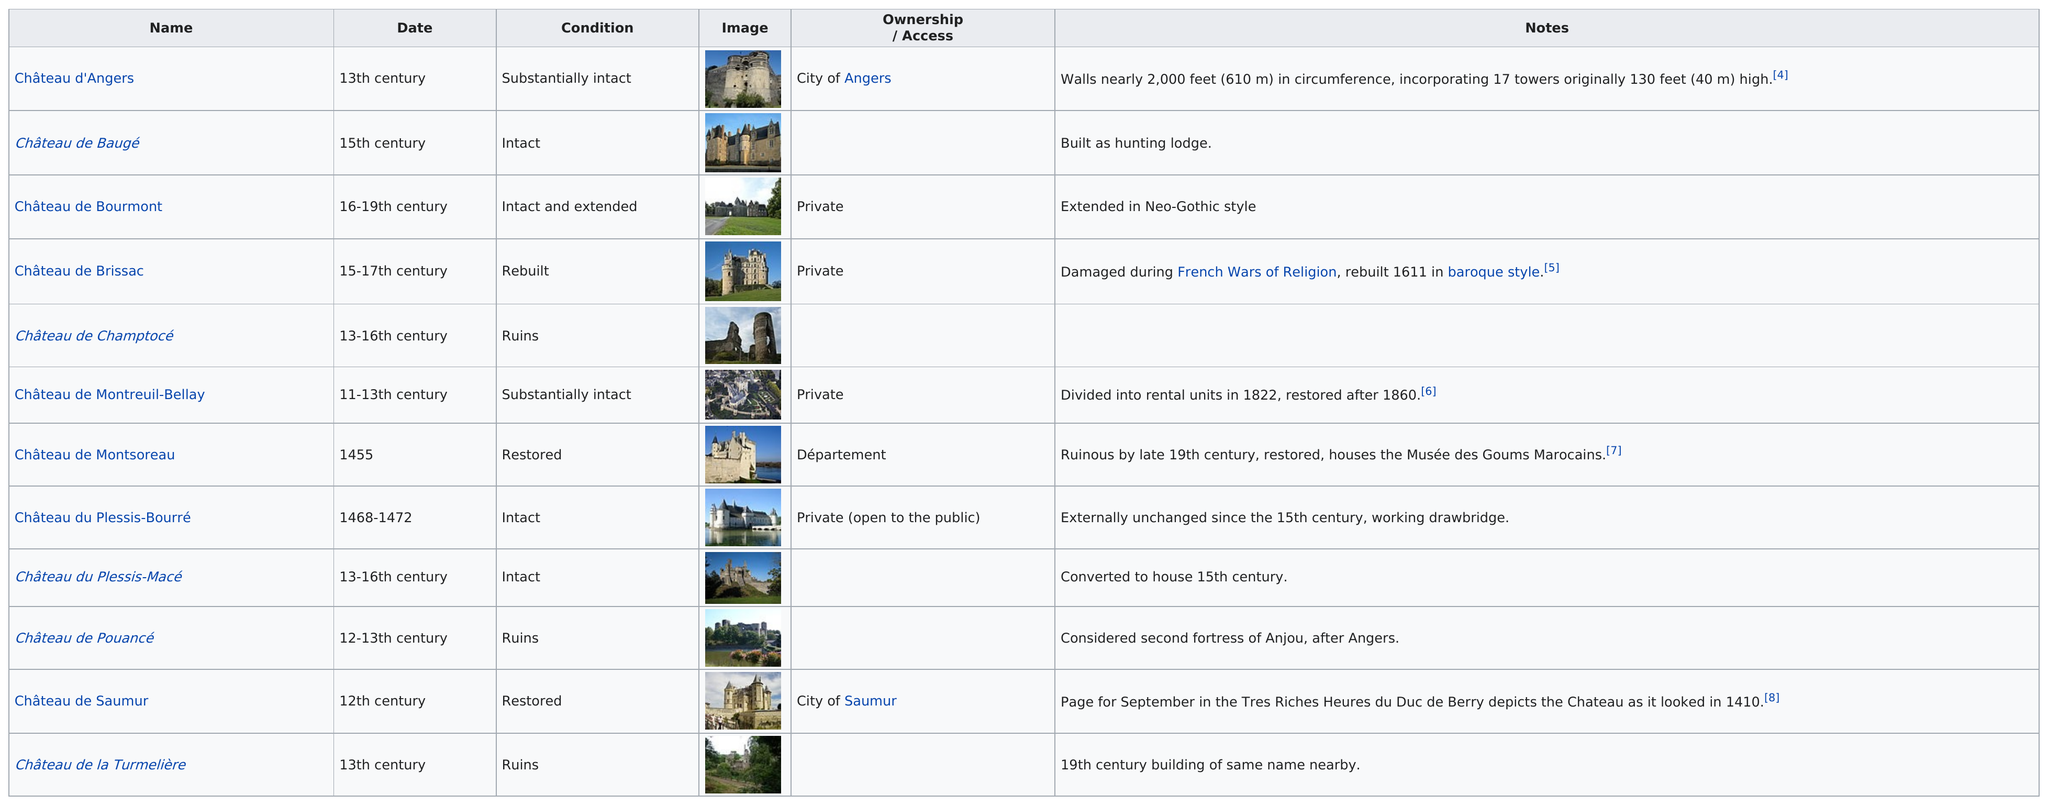List a handful of essential elements in this visual. Nearly three out of these castles are currently in ruins. The Château de Baugé was the only castle to be built as a hunting lodge. Eight of them are not private. The château d'Angers has 17 towers. The château that comes after Château de Bourmont is Château de Brissac. 